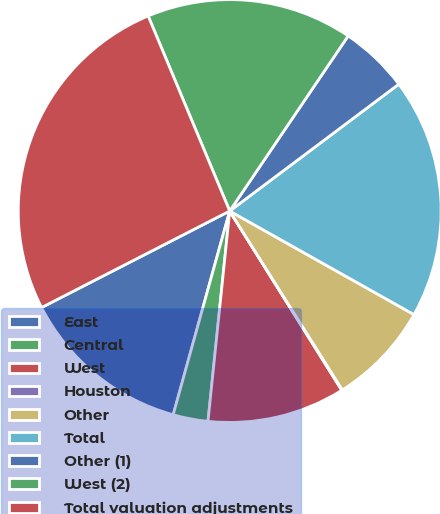Convert chart. <chart><loc_0><loc_0><loc_500><loc_500><pie_chart><fcel>East<fcel>Central<fcel>West<fcel>Houston<fcel>Other<fcel>Total<fcel>Other (1)<fcel>West (2)<fcel>Total valuation adjustments<nl><fcel>13.15%<fcel>2.67%<fcel>10.53%<fcel>0.05%<fcel>7.91%<fcel>18.39%<fcel>5.29%<fcel>15.77%<fcel>26.24%<nl></chart> 